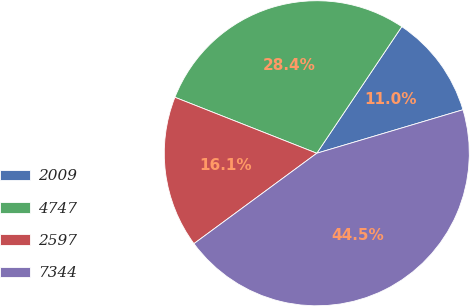Convert chart. <chart><loc_0><loc_0><loc_500><loc_500><pie_chart><fcel>2009<fcel>4747<fcel>2597<fcel>7344<nl><fcel>10.99%<fcel>28.43%<fcel>16.08%<fcel>44.51%<nl></chart> 